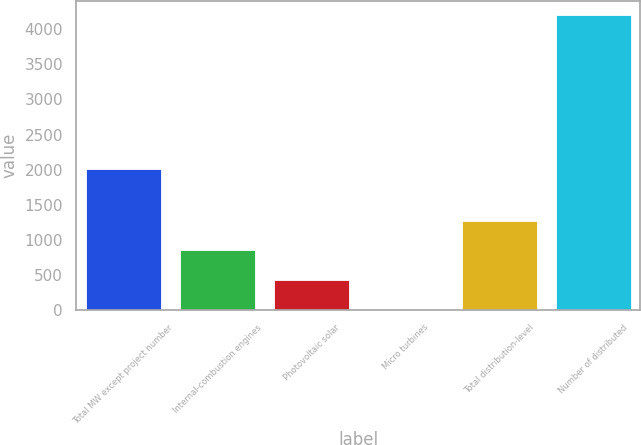Convert chart to OTSL. <chart><loc_0><loc_0><loc_500><loc_500><bar_chart><fcel>Total MW except project number<fcel>Internal-combustion engines<fcel>Photovoltaic solar<fcel>Micro turbines<fcel>Total distribution-level<fcel>Number of distributed<nl><fcel>2014<fcel>847.2<fcel>428.1<fcel>9<fcel>1266.3<fcel>4200<nl></chart> 